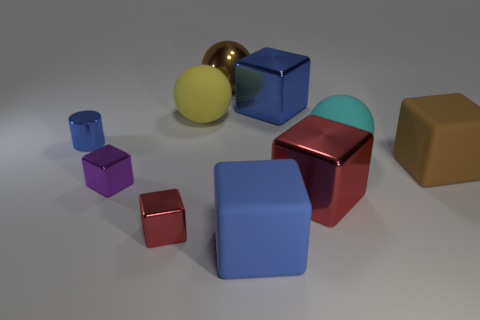Subtract all small purple cubes. How many cubes are left? 5 Subtract all brown blocks. How many blocks are left? 5 Subtract all brown cubes. Subtract all red cylinders. How many cubes are left? 5 Subtract all cylinders. How many objects are left? 9 Subtract all big red metallic cubes. Subtract all matte objects. How many objects are left? 5 Add 8 big brown matte cubes. How many big brown matte cubes are left? 9 Add 6 large gray balls. How many large gray balls exist? 6 Subtract 0 gray balls. How many objects are left? 10 